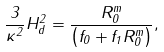Convert formula to latex. <formula><loc_0><loc_0><loc_500><loc_500>\frac { 3 } { \kappa ^ { 2 } } H ^ { 2 } _ { d } = \frac { R _ { 0 } ^ { m } } { \left ( f _ { 0 } + f _ { 1 } R _ { 0 } ^ { m } \right ) } ,</formula> 